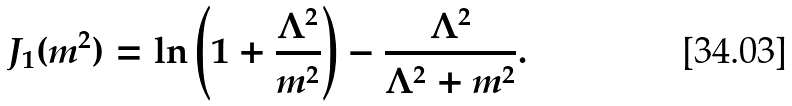<formula> <loc_0><loc_0><loc_500><loc_500>J _ { 1 } ( m ^ { 2 } ) = \ln \left ( 1 + \frac { \Lambda ^ { 2 } } { m ^ { 2 } } \right ) - \frac { \Lambda ^ { 2 } } { \Lambda ^ { 2 } + m ^ { 2 } } .</formula> 